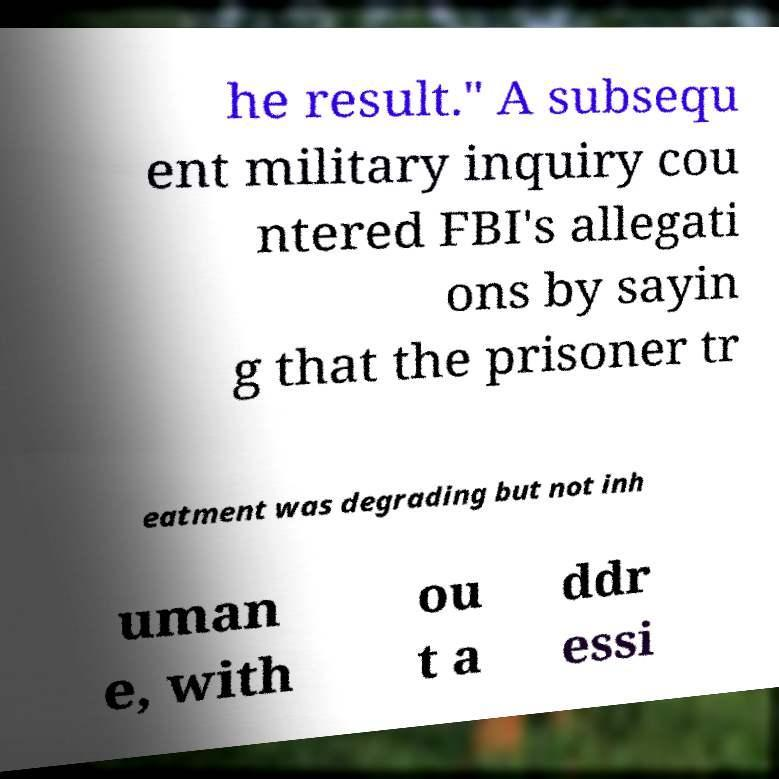Can you accurately transcribe the text from the provided image for me? he result." A subsequ ent military inquiry cou ntered FBI's allegati ons by sayin g that the prisoner tr eatment was degrading but not inh uman e, with ou t a ddr essi 